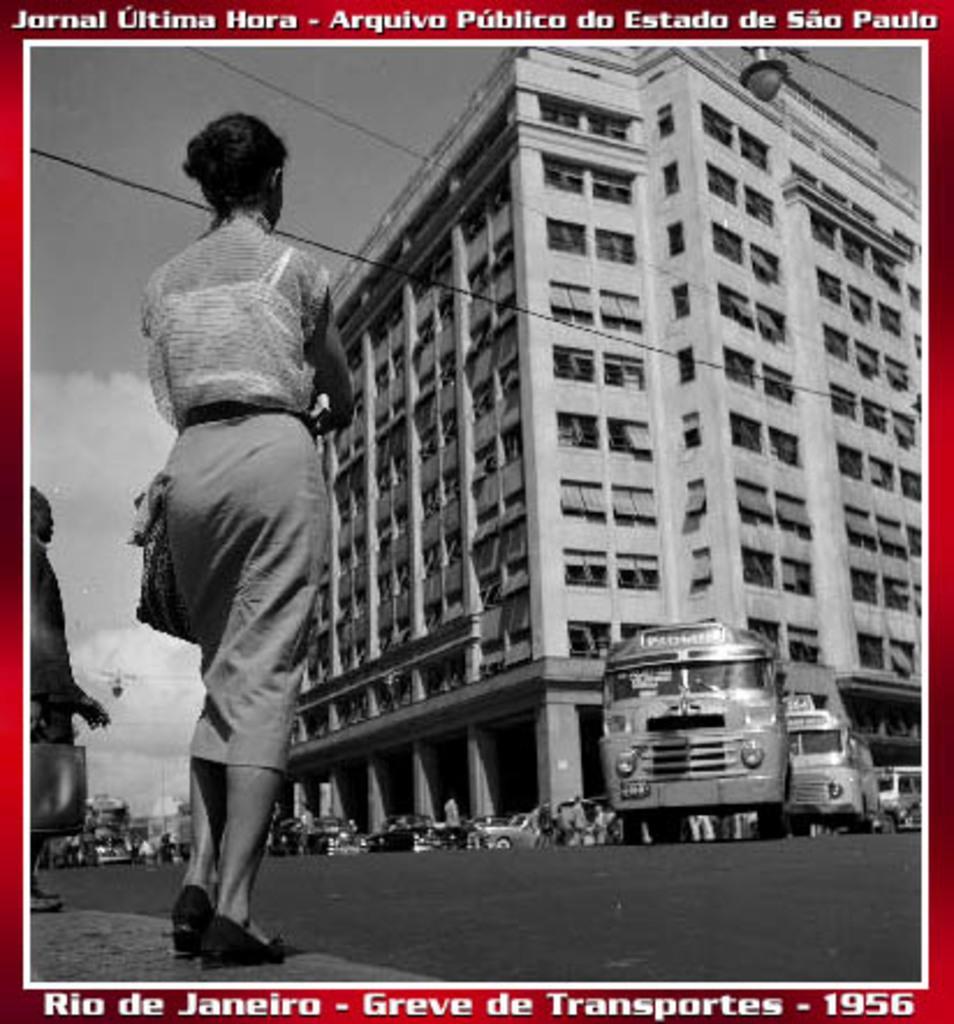Please provide a concise description of this image. In this image, we can see persons wearing clothes. There is a text at the top and at the bottom of the image. There are vehicles in front of the building. There are clouds in the sky. 